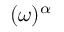Convert formula to latex. <formula><loc_0><loc_0><loc_500><loc_500>( \omega ) ^ { \alpha }</formula> 